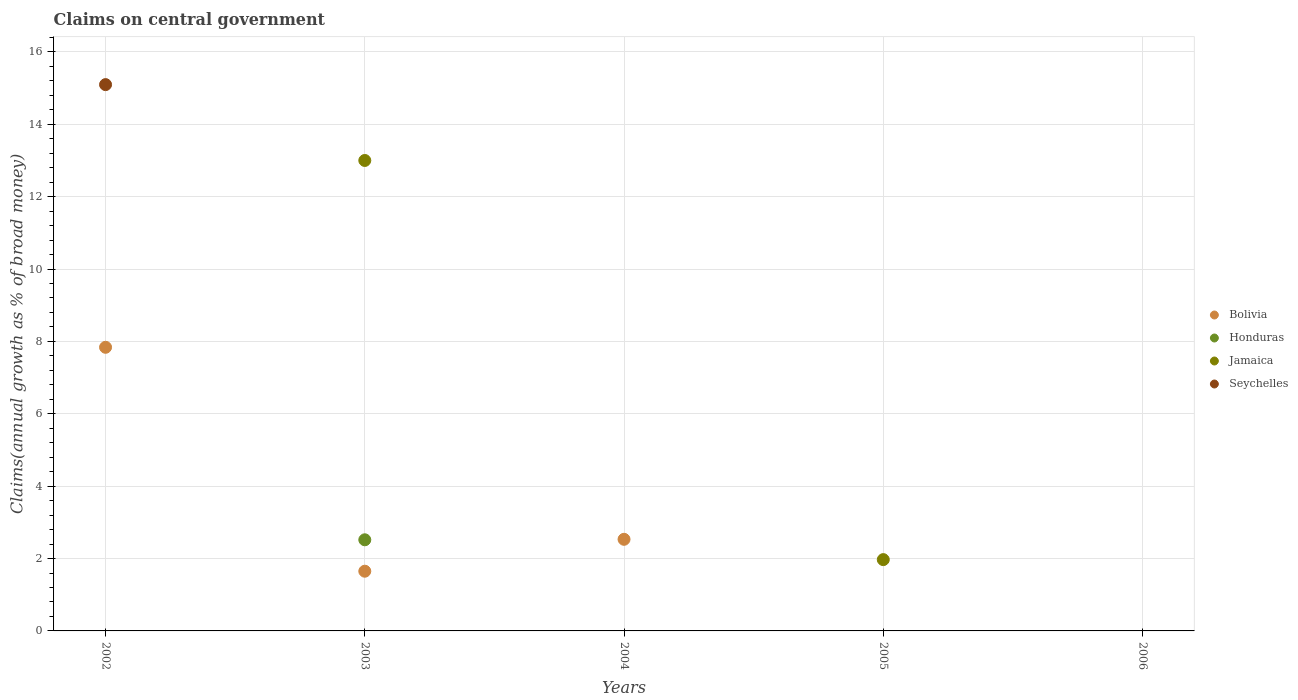Across all years, what is the maximum percentage of broad money claimed on centeral government in Bolivia?
Make the answer very short. 7.84. What is the total percentage of broad money claimed on centeral government in Jamaica in the graph?
Offer a very short reply. 14.97. What is the difference between the percentage of broad money claimed on centeral government in Bolivia in 2002 and that in 2004?
Your answer should be very brief. 5.31. What is the difference between the percentage of broad money claimed on centeral government in Seychelles in 2004 and the percentage of broad money claimed on centeral government in Jamaica in 2003?
Give a very brief answer. -13. What is the average percentage of broad money claimed on centeral government in Jamaica per year?
Ensure brevity in your answer.  2.99. In how many years, is the percentage of broad money claimed on centeral government in Jamaica greater than 5.6 %?
Your answer should be very brief. 1. What is the ratio of the percentage of broad money claimed on centeral government in Bolivia in 2002 to that in 2003?
Make the answer very short. 4.75. What is the difference between the highest and the second highest percentage of broad money claimed on centeral government in Bolivia?
Provide a short and direct response. 5.31. What is the difference between the highest and the lowest percentage of broad money claimed on centeral government in Seychelles?
Offer a terse response. 15.1. Is the sum of the percentage of broad money claimed on centeral government in Bolivia in 2002 and 2004 greater than the maximum percentage of broad money claimed on centeral government in Honduras across all years?
Give a very brief answer. Yes. Is it the case that in every year, the sum of the percentage of broad money claimed on centeral government in Seychelles and percentage of broad money claimed on centeral government in Jamaica  is greater than the percentage of broad money claimed on centeral government in Honduras?
Your response must be concise. No. How many years are there in the graph?
Your answer should be very brief. 5. Where does the legend appear in the graph?
Provide a succinct answer. Center right. How are the legend labels stacked?
Your answer should be compact. Vertical. What is the title of the graph?
Provide a succinct answer. Claims on central government. What is the label or title of the X-axis?
Provide a short and direct response. Years. What is the label or title of the Y-axis?
Make the answer very short. Claims(annual growth as % of broad money). What is the Claims(annual growth as % of broad money) in Bolivia in 2002?
Your answer should be very brief. 7.84. What is the Claims(annual growth as % of broad money) of Honduras in 2002?
Your answer should be very brief. 0. What is the Claims(annual growth as % of broad money) of Jamaica in 2002?
Provide a short and direct response. 0. What is the Claims(annual growth as % of broad money) in Seychelles in 2002?
Your answer should be very brief. 15.1. What is the Claims(annual growth as % of broad money) in Bolivia in 2003?
Your response must be concise. 1.65. What is the Claims(annual growth as % of broad money) in Honduras in 2003?
Keep it short and to the point. 2.52. What is the Claims(annual growth as % of broad money) in Jamaica in 2003?
Ensure brevity in your answer.  13. What is the Claims(annual growth as % of broad money) in Bolivia in 2004?
Keep it short and to the point. 2.53. What is the Claims(annual growth as % of broad money) of Honduras in 2004?
Make the answer very short. 0. What is the Claims(annual growth as % of broad money) of Jamaica in 2004?
Ensure brevity in your answer.  0. What is the Claims(annual growth as % of broad money) of Seychelles in 2004?
Your response must be concise. 0. What is the Claims(annual growth as % of broad money) in Bolivia in 2005?
Offer a very short reply. 0. What is the Claims(annual growth as % of broad money) in Jamaica in 2005?
Give a very brief answer. 1.97. What is the Claims(annual growth as % of broad money) of Bolivia in 2006?
Give a very brief answer. 0. What is the Claims(annual growth as % of broad money) of Honduras in 2006?
Make the answer very short. 0. What is the Claims(annual growth as % of broad money) in Seychelles in 2006?
Keep it short and to the point. 0. Across all years, what is the maximum Claims(annual growth as % of broad money) in Bolivia?
Ensure brevity in your answer.  7.84. Across all years, what is the maximum Claims(annual growth as % of broad money) of Honduras?
Provide a short and direct response. 2.52. Across all years, what is the maximum Claims(annual growth as % of broad money) of Jamaica?
Offer a very short reply. 13. Across all years, what is the maximum Claims(annual growth as % of broad money) of Seychelles?
Provide a short and direct response. 15.1. Across all years, what is the minimum Claims(annual growth as % of broad money) of Honduras?
Your answer should be compact. 0. What is the total Claims(annual growth as % of broad money) in Bolivia in the graph?
Ensure brevity in your answer.  12.02. What is the total Claims(annual growth as % of broad money) of Honduras in the graph?
Keep it short and to the point. 2.52. What is the total Claims(annual growth as % of broad money) in Jamaica in the graph?
Offer a very short reply. 14.97. What is the total Claims(annual growth as % of broad money) in Seychelles in the graph?
Ensure brevity in your answer.  15.1. What is the difference between the Claims(annual growth as % of broad money) in Bolivia in 2002 and that in 2003?
Give a very brief answer. 6.19. What is the difference between the Claims(annual growth as % of broad money) in Bolivia in 2002 and that in 2004?
Your answer should be compact. 5.31. What is the difference between the Claims(annual growth as % of broad money) in Bolivia in 2003 and that in 2004?
Your answer should be compact. -0.88. What is the difference between the Claims(annual growth as % of broad money) of Jamaica in 2003 and that in 2005?
Your response must be concise. 11.03. What is the difference between the Claims(annual growth as % of broad money) in Bolivia in 2002 and the Claims(annual growth as % of broad money) in Honduras in 2003?
Provide a succinct answer. 5.32. What is the difference between the Claims(annual growth as % of broad money) of Bolivia in 2002 and the Claims(annual growth as % of broad money) of Jamaica in 2003?
Make the answer very short. -5.16. What is the difference between the Claims(annual growth as % of broad money) in Bolivia in 2002 and the Claims(annual growth as % of broad money) in Jamaica in 2005?
Ensure brevity in your answer.  5.87. What is the difference between the Claims(annual growth as % of broad money) of Bolivia in 2003 and the Claims(annual growth as % of broad money) of Jamaica in 2005?
Make the answer very short. -0.32. What is the difference between the Claims(annual growth as % of broad money) of Honduras in 2003 and the Claims(annual growth as % of broad money) of Jamaica in 2005?
Provide a short and direct response. 0.55. What is the difference between the Claims(annual growth as % of broad money) in Bolivia in 2004 and the Claims(annual growth as % of broad money) in Jamaica in 2005?
Your answer should be compact. 0.56. What is the average Claims(annual growth as % of broad money) of Bolivia per year?
Ensure brevity in your answer.  2.4. What is the average Claims(annual growth as % of broad money) of Honduras per year?
Provide a succinct answer. 0.5. What is the average Claims(annual growth as % of broad money) of Jamaica per year?
Offer a terse response. 2.99. What is the average Claims(annual growth as % of broad money) of Seychelles per year?
Your response must be concise. 3.02. In the year 2002, what is the difference between the Claims(annual growth as % of broad money) of Bolivia and Claims(annual growth as % of broad money) of Seychelles?
Your answer should be compact. -7.26. In the year 2003, what is the difference between the Claims(annual growth as % of broad money) in Bolivia and Claims(annual growth as % of broad money) in Honduras?
Offer a terse response. -0.87. In the year 2003, what is the difference between the Claims(annual growth as % of broad money) in Bolivia and Claims(annual growth as % of broad money) in Jamaica?
Make the answer very short. -11.35. In the year 2003, what is the difference between the Claims(annual growth as % of broad money) in Honduras and Claims(annual growth as % of broad money) in Jamaica?
Give a very brief answer. -10.48. What is the ratio of the Claims(annual growth as % of broad money) of Bolivia in 2002 to that in 2003?
Provide a succinct answer. 4.75. What is the ratio of the Claims(annual growth as % of broad money) in Bolivia in 2002 to that in 2004?
Keep it short and to the point. 3.1. What is the ratio of the Claims(annual growth as % of broad money) of Bolivia in 2003 to that in 2004?
Keep it short and to the point. 0.65. What is the ratio of the Claims(annual growth as % of broad money) of Jamaica in 2003 to that in 2005?
Your answer should be compact. 6.6. What is the difference between the highest and the second highest Claims(annual growth as % of broad money) of Bolivia?
Your response must be concise. 5.31. What is the difference between the highest and the lowest Claims(annual growth as % of broad money) of Bolivia?
Your answer should be compact. 7.84. What is the difference between the highest and the lowest Claims(annual growth as % of broad money) of Honduras?
Keep it short and to the point. 2.52. What is the difference between the highest and the lowest Claims(annual growth as % of broad money) of Jamaica?
Provide a short and direct response. 13. What is the difference between the highest and the lowest Claims(annual growth as % of broad money) in Seychelles?
Provide a succinct answer. 15.1. 